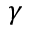<formula> <loc_0><loc_0><loc_500><loc_500>\gamma</formula> 